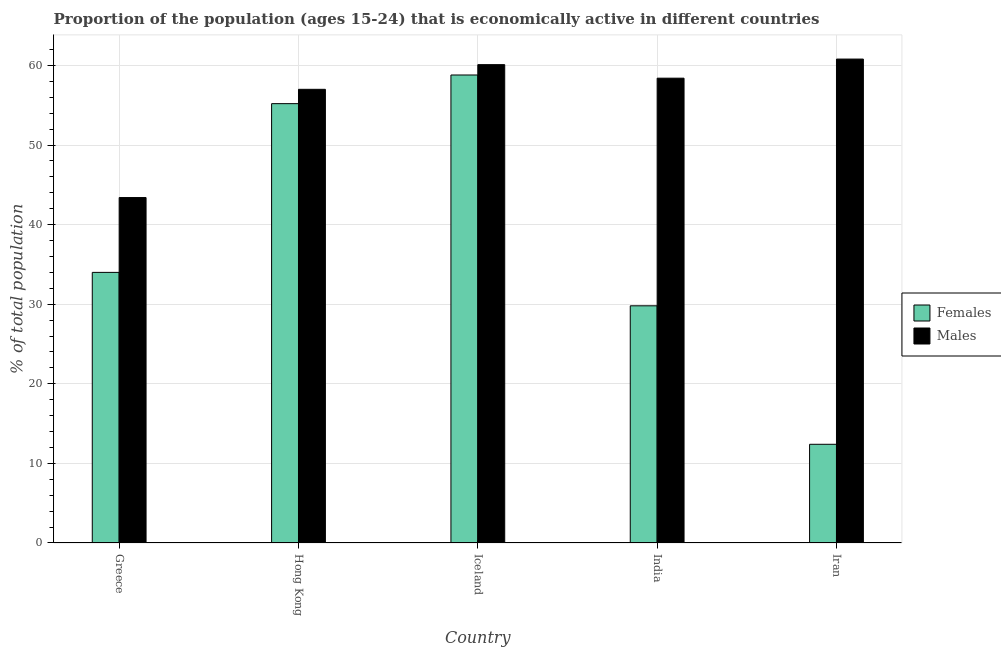How many different coloured bars are there?
Offer a terse response. 2. How many groups of bars are there?
Give a very brief answer. 5. Are the number of bars on each tick of the X-axis equal?
Provide a succinct answer. Yes. How many bars are there on the 2nd tick from the left?
Keep it short and to the point. 2. In how many cases, is the number of bars for a given country not equal to the number of legend labels?
Your response must be concise. 0. What is the percentage of economically active male population in Iceland?
Keep it short and to the point. 60.1. Across all countries, what is the maximum percentage of economically active female population?
Offer a very short reply. 58.8. Across all countries, what is the minimum percentage of economically active female population?
Give a very brief answer. 12.4. In which country was the percentage of economically active male population minimum?
Your answer should be compact. Greece. What is the total percentage of economically active female population in the graph?
Your response must be concise. 190.2. What is the difference between the percentage of economically active female population in Hong Kong and that in Iran?
Offer a terse response. 42.8. What is the difference between the percentage of economically active female population in Iran and the percentage of economically active male population in Iceland?
Your response must be concise. -47.7. What is the average percentage of economically active male population per country?
Offer a terse response. 55.94. What is the difference between the percentage of economically active female population and percentage of economically active male population in India?
Provide a succinct answer. -28.6. What is the ratio of the percentage of economically active male population in Iceland to that in India?
Ensure brevity in your answer.  1.03. Is the difference between the percentage of economically active female population in Greece and Hong Kong greater than the difference between the percentage of economically active male population in Greece and Hong Kong?
Your answer should be compact. No. What is the difference between the highest and the second highest percentage of economically active male population?
Keep it short and to the point. 0.7. What is the difference between the highest and the lowest percentage of economically active male population?
Provide a succinct answer. 17.4. In how many countries, is the percentage of economically active female population greater than the average percentage of economically active female population taken over all countries?
Your answer should be compact. 2. What does the 1st bar from the left in Hong Kong represents?
Your answer should be very brief. Females. What does the 1st bar from the right in Hong Kong represents?
Provide a short and direct response. Males. How many countries are there in the graph?
Your answer should be compact. 5. What is the difference between two consecutive major ticks on the Y-axis?
Keep it short and to the point. 10. Does the graph contain grids?
Offer a terse response. Yes. Where does the legend appear in the graph?
Keep it short and to the point. Center right. How are the legend labels stacked?
Your answer should be very brief. Vertical. What is the title of the graph?
Offer a terse response. Proportion of the population (ages 15-24) that is economically active in different countries. What is the label or title of the X-axis?
Keep it short and to the point. Country. What is the label or title of the Y-axis?
Your answer should be compact. % of total population. What is the % of total population in Males in Greece?
Provide a succinct answer. 43.4. What is the % of total population in Females in Hong Kong?
Your response must be concise. 55.2. What is the % of total population of Females in Iceland?
Ensure brevity in your answer.  58.8. What is the % of total population in Males in Iceland?
Provide a short and direct response. 60.1. What is the % of total population of Females in India?
Provide a short and direct response. 29.8. What is the % of total population of Males in India?
Provide a succinct answer. 58.4. What is the % of total population of Females in Iran?
Provide a succinct answer. 12.4. What is the % of total population in Males in Iran?
Offer a terse response. 60.8. Across all countries, what is the maximum % of total population in Females?
Ensure brevity in your answer.  58.8. Across all countries, what is the maximum % of total population of Males?
Keep it short and to the point. 60.8. Across all countries, what is the minimum % of total population in Females?
Ensure brevity in your answer.  12.4. Across all countries, what is the minimum % of total population of Males?
Provide a succinct answer. 43.4. What is the total % of total population of Females in the graph?
Your answer should be very brief. 190.2. What is the total % of total population in Males in the graph?
Give a very brief answer. 279.7. What is the difference between the % of total population in Females in Greece and that in Hong Kong?
Give a very brief answer. -21.2. What is the difference between the % of total population in Males in Greece and that in Hong Kong?
Make the answer very short. -13.6. What is the difference between the % of total population in Females in Greece and that in Iceland?
Your response must be concise. -24.8. What is the difference between the % of total population of Males in Greece and that in Iceland?
Keep it short and to the point. -16.7. What is the difference between the % of total population of Females in Greece and that in Iran?
Provide a short and direct response. 21.6. What is the difference between the % of total population of Males in Greece and that in Iran?
Offer a terse response. -17.4. What is the difference between the % of total population in Females in Hong Kong and that in Iceland?
Provide a short and direct response. -3.6. What is the difference between the % of total population in Females in Hong Kong and that in India?
Give a very brief answer. 25.4. What is the difference between the % of total population in Females in Hong Kong and that in Iran?
Offer a very short reply. 42.8. What is the difference between the % of total population in Males in Hong Kong and that in Iran?
Your answer should be very brief. -3.8. What is the difference between the % of total population of Females in Iceland and that in India?
Offer a terse response. 29. What is the difference between the % of total population of Females in Iceland and that in Iran?
Offer a terse response. 46.4. What is the difference between the % of total population of Males in India and that in Iran?
Provide a succinct answer. -2.4. What is the difference between the % of total population of Females in Greece and the % of total population of Males in Iceland?
Your answer should be compact. -26.1. What is the difference between the % of total population of Females in Greece and the % of total population of Males in India?
Your response must be concise. -24.4. What is the difference between the % of total population in Females in Greece and the % of total population in Males in Iran?
Keep it short and to the point. -26.8. What is the difference between the % of total population in Females in Hong Kong and the % of total population in Males in Iceland?
Your answer should be compact. -4.9. What is the difference between the % of total population of Females in Hong Kong and the % of total population of Males in Iran?
Offer a very short reply. -5.6. What is the difference between the % of total population in Females in Iceland and the % of total population in Males in India?
Give a very brief answer. 0.4. What is the difference between the % of total population in Females in India and the % of total population in Males in Iran?
Your response must be concise. -31. What is the average % of total population in Females per country?
Your answer should be compact. 38.04. What is the average % of total population in Males per country?
Offer a terse response. 55.94. What is the difference between the % of total population in Females and % of total population in Males in India?
Offer a terse response. -28.6. What is the difference between the % of total population of Females and % of total population of Males in Iran?
Offer a terse response. -48.4. What is the ratio of the % of total population of Females in Greece to that in Hong Kong?
Provide a succinct answer. 0.62. What is the ratio of the % of total population in Males in Greece to that in Hong Kong?
Offer a very short reply. 0.76. What is the ratio of the % of total population of Females in Greece to that in Iceland?
Provide a short and direct response. 0.58. What is the ratio of the % of total population of Males in Greece to that in Iceland?
Ensure brevity in your answer.  0.72. What is the ratio of the % of total population of Females in Greece to that in India?
Give a very brief answer. 1.14. What is the ratio of the % of total population of Males in Greece to that in India?
Your answer should be compact. 0.74. What is the ratio of the % of total population in Females in Greece to that in Iran?
Make the answer very short. 2.74. What is the ratio of the % of total population in Males in Greece to that in Iran?
Offer a very short reply. 0.71. What is the ratio of the % of total population of Females in Hong Kong to that in Iceland?
Your answer should be compact. 0.94. What is the ratio of the % of total population of Males in Hong Kong to that in Iceland?
Offer a terse response. 0.95. What is the ratio of the % of total population of Females in Hong Kong to that in India?
Keep it short and to the point. 1.85. What is the ratio of the % of total population in Females in Hong Kong to that in Iran?
Offer a very short reply. 4.45. What is the ratio of the % of total population in Females in Iceland to that in India?
Provide a short and direct response. 1.97. What is the ratio of the % of total population in Males in Iceland to that in India?
Your answer should be compact. 1.03. What is the ratio of the % of total population in Females in Iceland to that in Iran?
Offer a very short reply. 4.74. What is the ratio of the % of total population of Females in India to that in Iran?
Offer a very short reply. 2.4. What is the ratio of the % of total population in Males in India to that in Iran?
Offer a very short reply. 0.96. What is the difference between the highest and the second highest % of total population in Males?
Offer a terse response. 0.7. What is the difference between the highest and the lowest % of total population in Females?
Offer a very short reply. 46.4. What is the difference between the highest and the lowest % of total population of Males?
Keep it short and to the point. 17.4. 